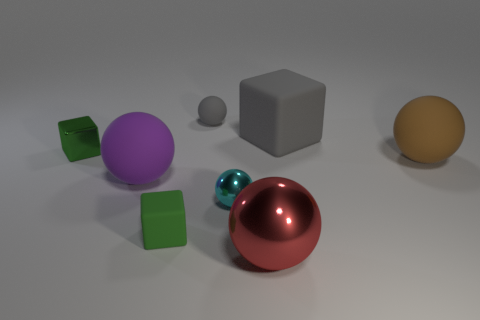Subtract all tiny spheres. How many spheres are left? 3 Subtract 2 balls. How many balls are left? 3 Subtract all gray balls. How many balls are left? 4 Subtract all spheres. How many objects are left? 3 Subtract all brown spheres. How many brown blocks are left? 0 Subtract all large blocks. Subtract all tiny cyan shiny balls. How many objects are left? 6 Add 8 red metallic objects. How many red metallic objects are left? 9 Add 7 purple spheres. How many purple spheres exist? 8 Add 1 large purple matte spheres. How many objects exist? 9 Subtract 1 cyan balls. How many objects are left? 7 